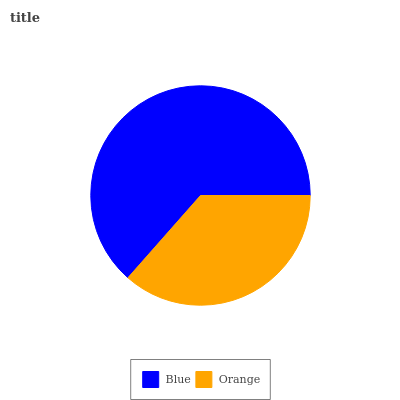Is Orange the minimum?
Answer yes or no. Yes. Is Blue the maximum?
Answer yes or no. Yes. Is Orange the maximum?
Answer yes or no. No. Is Blue greater than Orange?
Answer yes or no. Yes. Is Orange less than Blue?
Answer yes or no. Yes. Is Orange greater than Blue?
Answer yes or no. No. Is Blue less than Orange?
Answer yes or no. No. Is Blue the high median?
Answer yes or no. Yes. Is Orange the low median?
Answer yes or no. Yes. Is Orange the high median?
Answer yes or no. No. Is Blue the low median?
Answer yes or no. No. 